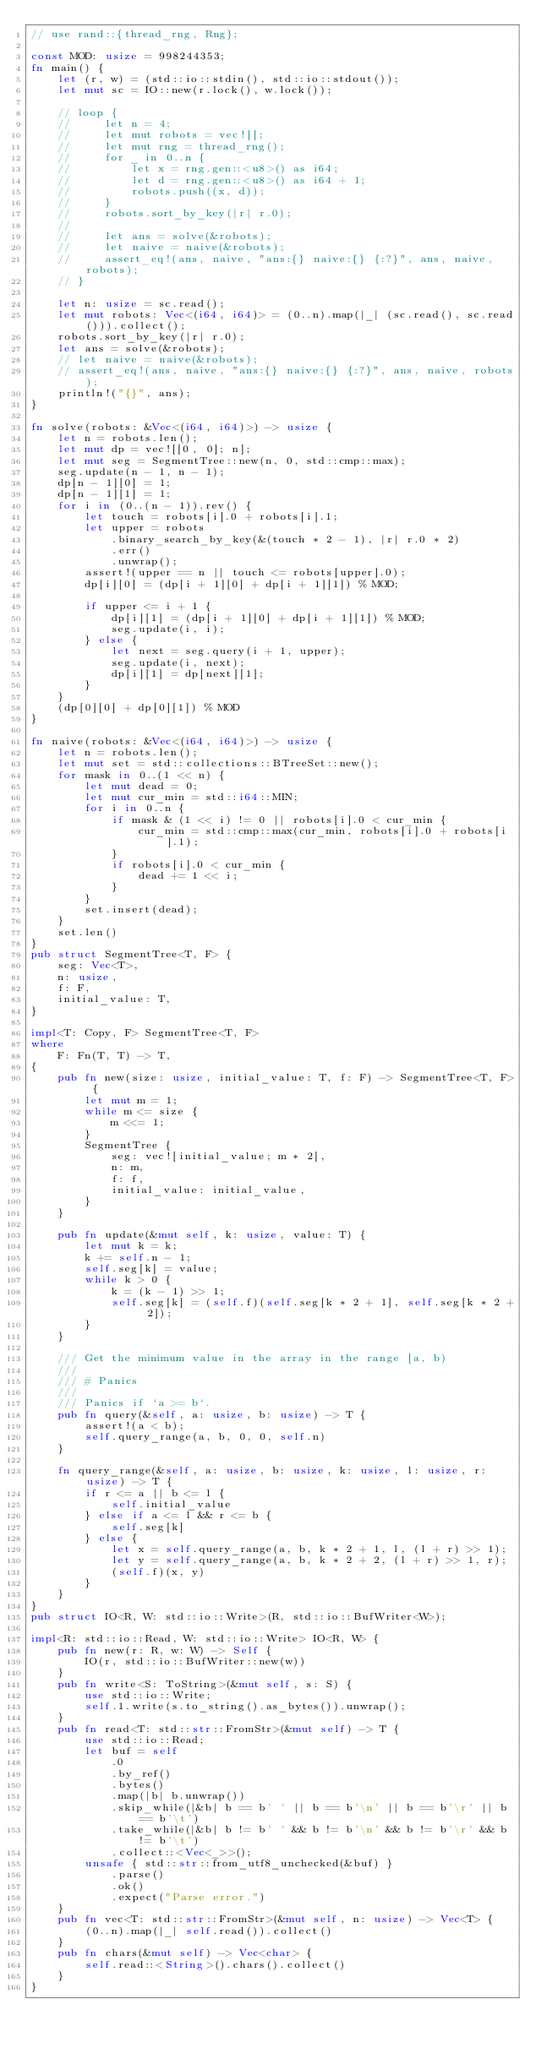Convert code to text. <code><loc_0><loc_0><loc_500><loc_500><_Rust_>// use rand::{thread_rng, Rng};

const MOD: usize = 998244353;
fn main() {
    let (r, w) = (std::io::stdin(), std::io::stdout());
    let mut sc = IO::new(r.lock(), w.lock());

    // loop {
    //     let n = 4;
    //     let mut robots = vec![];
    //     let mut rng = thread_rng();
    //     for _ in 0..n {
    //         let x = rng.gen::<u8>() as i64;
    //         let d = rng.gen::<u8>() as i64 + 1;
    //         robots.push((x, d));
    //     }
    //     robots.sort_by_key(|r| r.0);
    //
    //     let ans = solve(&robots);
    //     let naive = naive(&robots);
    //     assert_eq!(ans, naive, "ans:{} naive:{} {:?}", ans, naive, robots);
    // }

    let n: usize = sc.read();
    let mut robots: Vec<(i64, i64)> = (0..n).map(|_| (sc.read(), sc.read())).collect();
    robots.sort_by_key(|r| r.0);
    let ans = solve(&robots);
    // let naive = naive(&robots);
    // assert_eq!(ans, naive, "ans:{} naive:{} {:?}", ans, naive, robots);
    println!("{}", ans);
}

fn solve(robots: &Vec<(i64, i64)>) -> usize {
    let n = robots.len();
    let mut dp = vec![[0, 0]; n];
    let mut seg = SegmentTree::new(n, 0, std::cmp::max);
    seg.update(n - 1, n - 1);
    dp[n - 1][0] = 1;
    dp[n - 1][1] = 1;
    for i in (0..(n - 1)).rev() {
        let touch = robots[i].0 + robots[i].1;
        let upper = robots
            .binary_search_by_key(&(touch * 2 - 1), |r| r.0 * 2)
            .err()
            .unwrap();
        assert!(upper == n || touch <= robots[upper].0);
        dp[i][0] = (dp[i + 1][0] + dp[i + 1][1]) % MOD;

        if upper <= i + 1 {
            dp[i][1] = (dp[i + 1][0] + dp[i + 1][1]) % MOD;
            seg.update(i, i);
        } else {
            let next = seg.query(i + 1, upper);
            seg.update(i, next);
            dp[i][1] = dp[next][1];
        }
    }
    (dp[0][0] + dp[0][1]) % MOD
}

fn naive(robots: &Vec<(i64, i64)>) -> usize {
    let n = robots.len();
    let mut set = std::collections::BTreeSet::new();
    for mask in 0..(1 << n) {
        let mut dead = 0;
        let mut cur_min = std::i64::MIN;
        for i in 0..n {
            if mask & (1 << i) != 0 || robots[i].0 < cur_min {
                cur_min = std::cmp::max(cur_min, robots[i].0 + robots[i].1);
            }
            if robots[i].0 < cur_min {
                dead += 1 << i;
            }
        }
        set.insert(dead);
    }
    set.len()
}
pub struct SegmentTree<T, F> {
    seg: Vec<T>,
    n: usize,
    f: F,
    initial_value: T,
}

impl<T: Copy, F> SegmentTree<T, F>
where
    F: Fn(T, T) -> T,
{
    pub fn new(size: usize, initial_value: T, f: F) -> SegmentTree<T, F> {
        let mut m = 1;
        while m <= size {
            m <<= 1;
        }
        SegmentTree {
            seg: vec![initial_value; m * 2],
            n: m,
            f: f,
            initial_value: initial_value,
        }
    }

    pub fn update(&mut self, k: usize, value: T) {
        let mut k = k;
        k += self.n - 1;
        self.seg[k] = value;
        while k > 0 {
            k = (k - 1) >> 1;
            self.seg[k] = (self.f)(self.seg[k * 2 + 1], self.seg[k * 2 + 2]);
        }
    }

    /// Get the minimum value in the array in the range [a, b)
    ///
    /// # Panics
    ///
    /// Panics if `a >= b`.
    pub fn query(&self, a: usize, b: usize) -> T {
        assert!(a < b);
        self.query_range(a, b, 0, 0, self.n)
    }

    fn query_range(&self, a: usize, b: usize, k: usize, l: usize, r: usize) -> T {
        if r <= a || b <= l {
            self.initial_value
        } else if a <= l && r <= b {
            self.seg[k]
        } else {
            let x = self.query_range(a, b, k * 2 + 1, l, (l + r) >> 1);
            let y = self.query_range(a, b, k * 2 + 2, (l + r) >> 1, r);
            (self.f)(x, y)
        }
    }
}
pub struct IO<R, W: std::io::Write>(R, std::io::BufWriter<W>);

impl<R: std::io::Read, W: std::io::Write> IO<R, W> {
    pub fn new(r: R, w: W) -> Self {
        IO(r, std::io::BufWriter::new(w))
    }
    pub fn write<S: ToString>(&mut self, s: S) {
        use std::io::Write;
        self.1.write(s.to_string().as_bytes()).unwrap();
    }
    pub fn read<T: std::str::FromStr>(&mut self) -> T {
        use std::io::Read;
        let buf = self
            .0
            .by_ref()
            .bytes()
            .map(|b| b.unwrap())
            .skip_while(|&b| b == b' ' || b == b'\n' || b == b'\r' || b == b'\t')
            .take_while(|&b| b != b' ' && b != b'\n' && b != b'\r' && b != b'\t')
            .collect::<Vec<_>>();
        unsafe { std::str::from_utf8_unchecked(&buf) }
            .parse()
            .ok()
            .expect("Parse error.")
    }
    pub fn vec<T: std::str::FromStr>(&mut self, n: usize) -> Vec<T> {
        (0..n).map(|_| self.read()).collect()
    }
    pub fn chars(&mut self) -> Vec<char> {
        self.read::<String>().chars().collect()
    }
}
</code> 